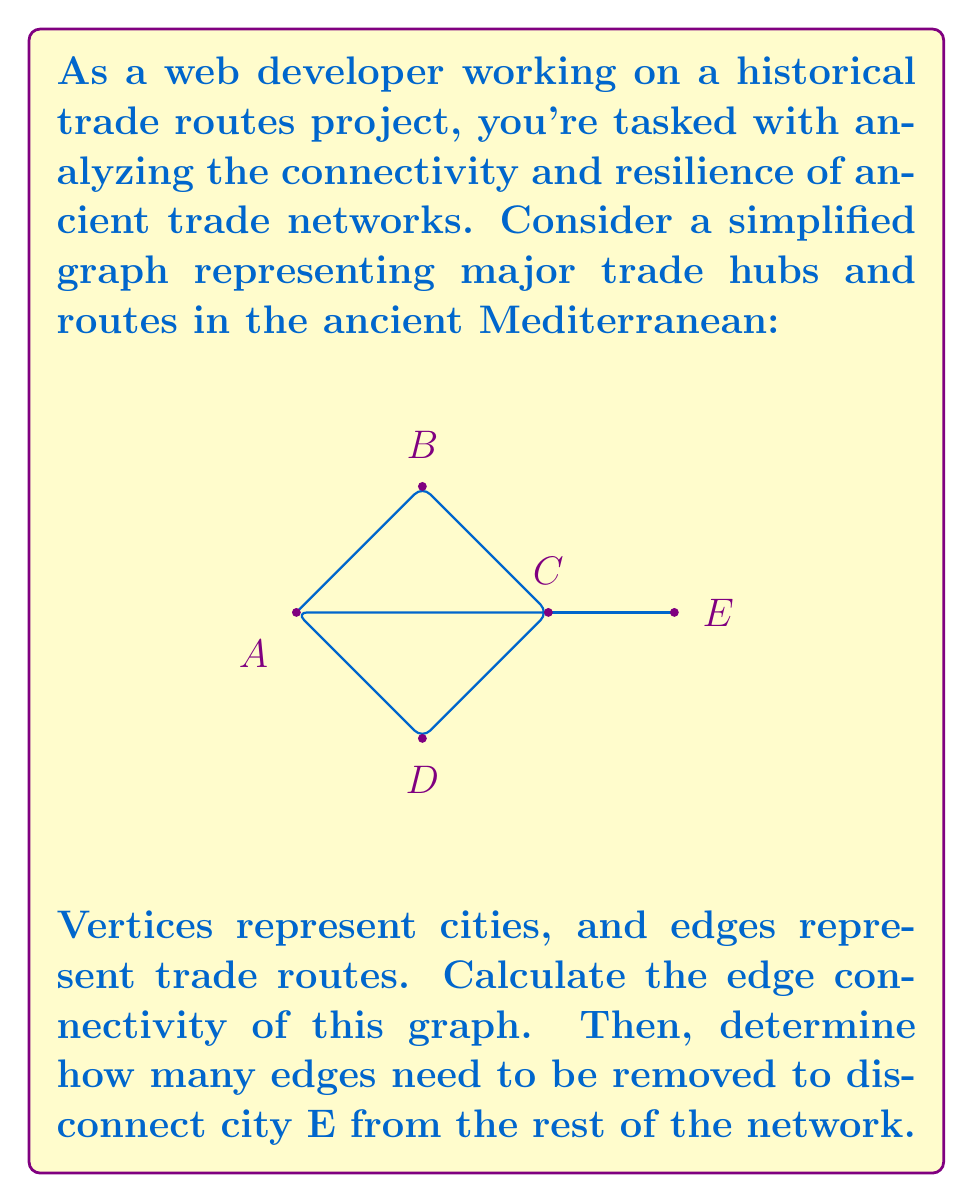Can you answer this question? To solve this problem, we'll use concepts from graph theory:

1. Edge connectivity:
   The edge connectivity of a graph is the minimum number of edges that need to be removed to disconnect the graph.

   In this graph:
   - Removing edges AC and CE disconnects the graph.
   - There's no way to disconnect the graph by removing only one edge.

   Therefore, the edge connectivity is 2.

2. Disconnecting city E:
   To disconnect E from the rest of the network, we need to remove all edges incident to E.
   There is only one edge connecting E to the rest of the graph: CE.

   Therefore, removing 1 edge (CE) disconnects E from the network.

This analysis helps us understand the resilience of the trade network:
- The overall network has moderate resilience (edge connectivity of 2).
- City E is vulnerable, as removing just one route isolates it.

As a web developer, you could use this information to create interactive visualizations showing the network's weak points and potential historical impacts of route disruptions.
Answer: Edge connectivity: 2
Edges to remove to disconnect E: 1 